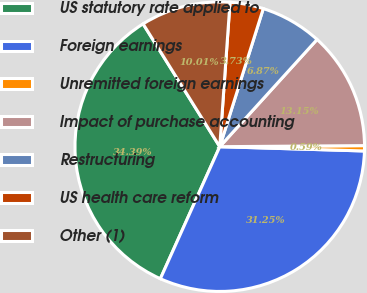Convert chart. <chart><loc_0><loc_0><loc_500><loc_500><pie_chart><fcel>US statutory rate applied to<fcel>Foreign earnings<fcel>Unremitted foreign earnings<fcel>Impact of purchase accounting<fcel>Restructuring<fcel>US health care reform<fcel>Other (1)<nl><fcel>34.39%<fcel>31.25%<fcel>0.59%<fcel>13.15%<fcel>6.87%<fcel>3.73%<fcel>10.01%<nl></chart> 